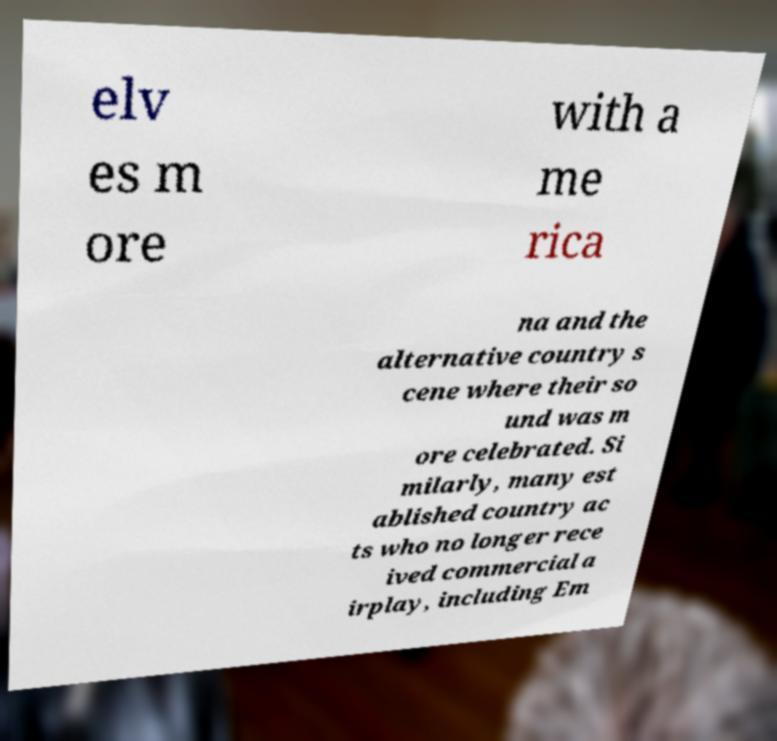There's text embedded in this image that I need extracted. Can you transcribe it verbatim? elv es m ore with a me rica na and the alternative country s cene where their so und was m ore celebrated. Si milarly, many est ablished country ac ts who no longer rece ived commercial a irplay, including Em 